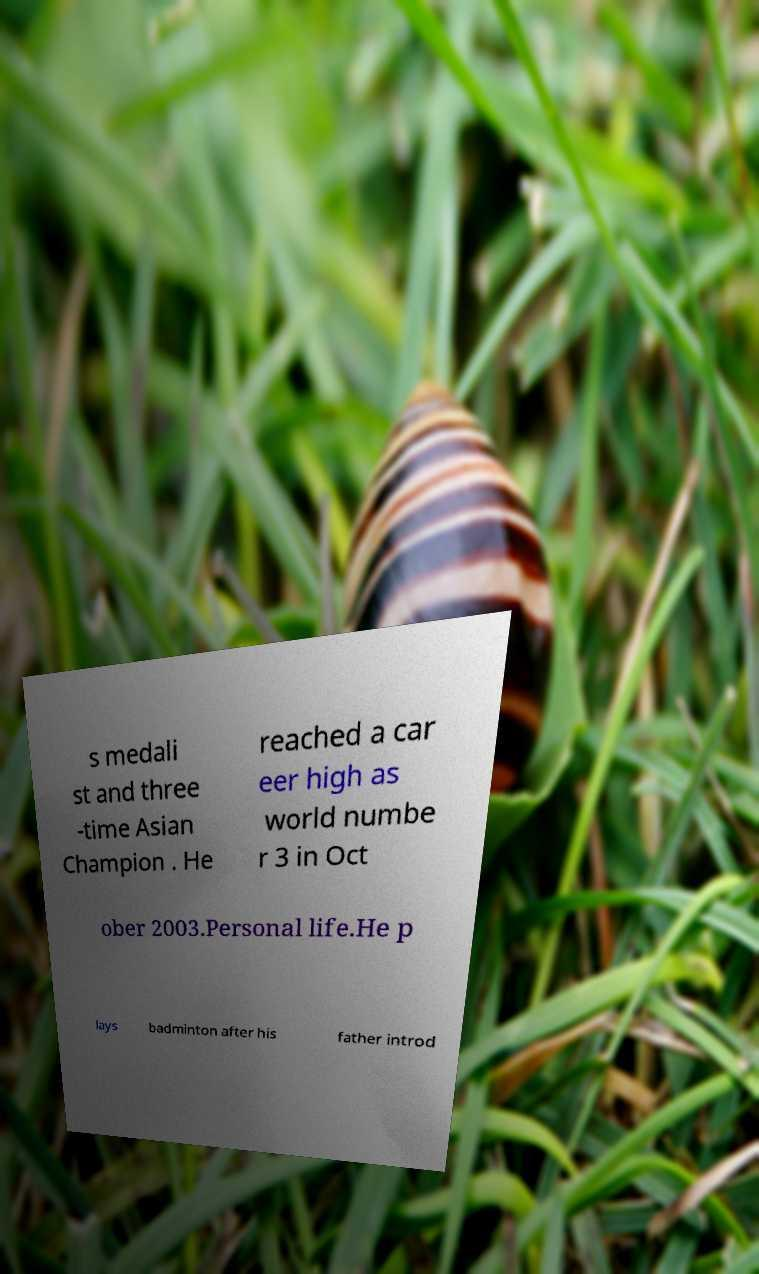For documentation purposes, I need the text within this image transcribed. Could you provide that? s medali st and three -time Asian Champion . He reached a car eer high as world numbe r 3 in Oct ober 2003.Personal life.He p lays badminton after his father introd 